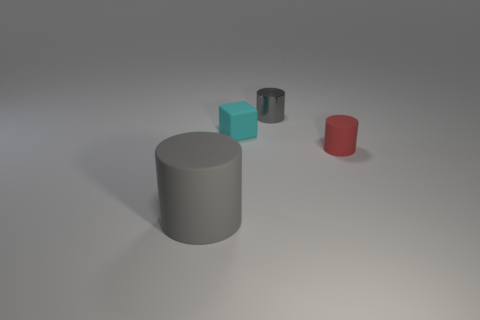There is another large cylinder that is the same color as the metallic cylinder; what is its material?
Your answer should be very brief. Rubber. Is there a big gray object of the same shape as the cyan matte object?
Give a very brief answer. No. There is a red matte cylinder; what number of rubber objects are in front of it?
Provide a succinct answer. 1. What material is the small red object that is behind the matte cylinder in front of the small red cylinder?
Your answer should be compact. Rubber. There is a gray thing that is the same size as the block; what is its material?
Your answer should be compact. Metal. Are there any brown shiny things that have the same size as the rubber cube?
Provide a succinct answer. No. There is a rubber thing behind the small red rubber thing; what color is it?
Offer a terse response. Cyan. Are there any matte things that are left of the rubber cylinder behind the large cylinder?
Offer a very short reply. Yes. What number of other objects are the same color as the small matte cube?
Keep it short and to the point. 0. There is a gray cylinder behind the big gray rubber thing; is its size the same as the matte object in front of the tiny red object?
Your answer should be compact. No. 